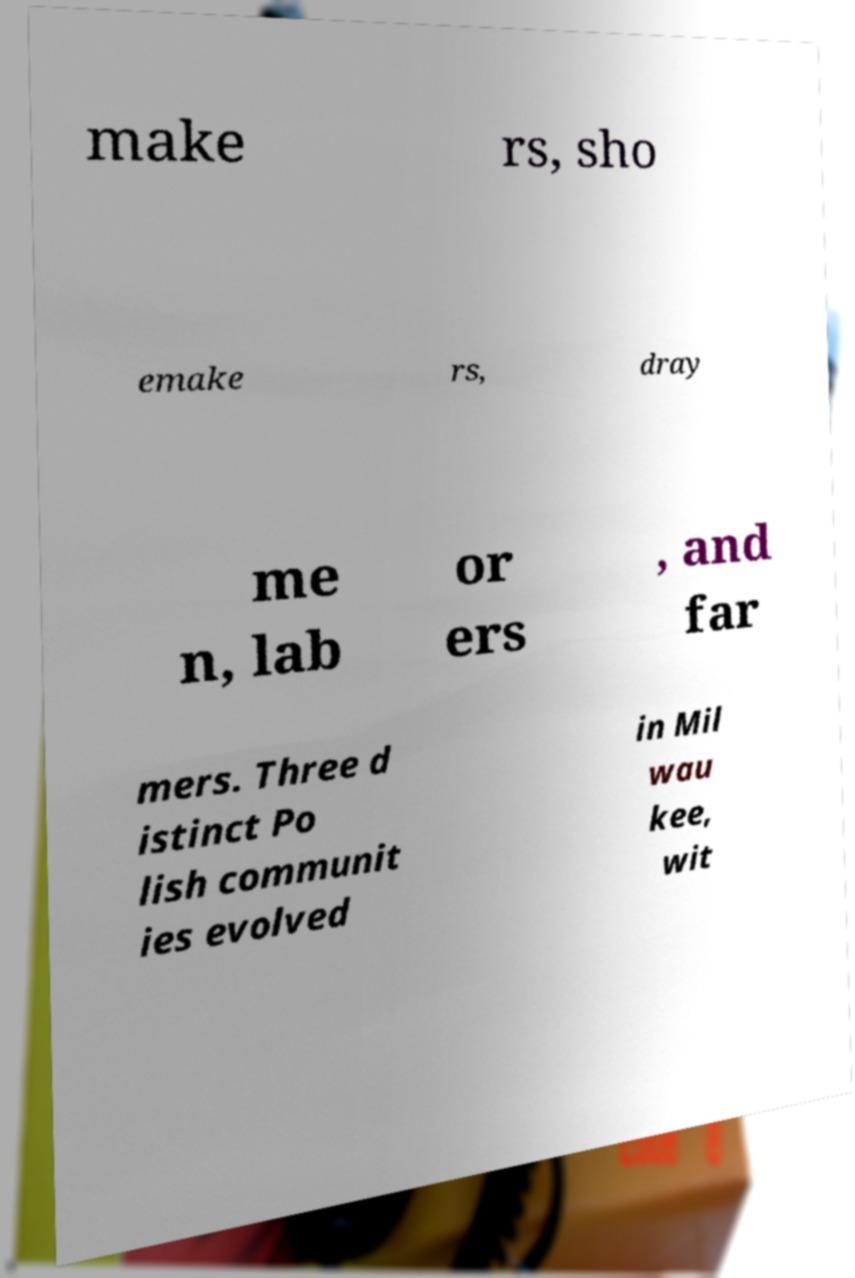I need the written content from this picture converted into text. Can you do that? make rs, sho emake rs, dray me n, lab or ers , and far mers. Three d istinct Po lish communit ies evolved in Mil wau kee, wit 